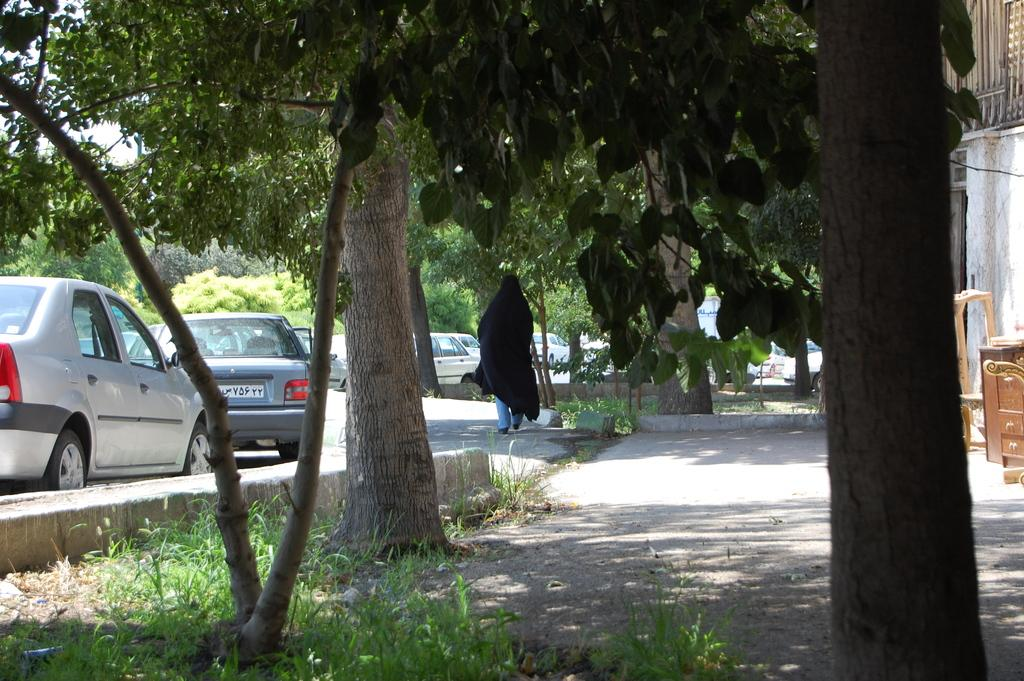What types of objects can be seen in the image? There are vehicles in the image. Can you describe the person in the image? There is a person on the ground in the image. What can be seen in the distance in the image? There are trees visible in the background of the image. What type of plastic material is being used by the horse in the image? There is no horse present in the image, so it is not possible to determine what type of plastic material might be used. 